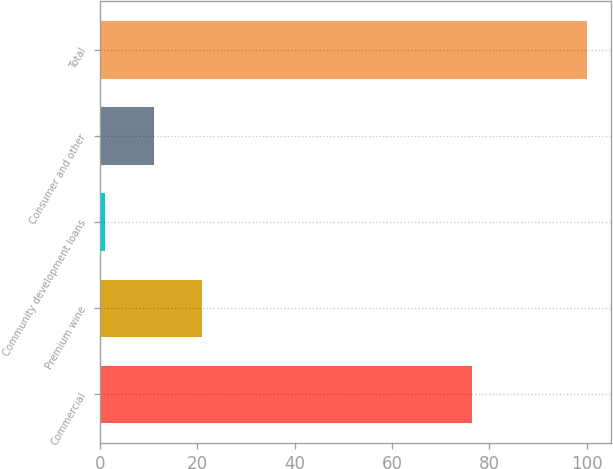Convert chart. <chart><loc_0><loc_0><loc_500><loc_500><bar_chart><fcel>Commercial<fcel>Premium wine<fcel>Community development loans<fcel>Consumer and other<fcel>Total<nl><fcel>76.4<fcel>20.88<fcel>1.1<fcel>10.99<fcel>100<nl></chart> 